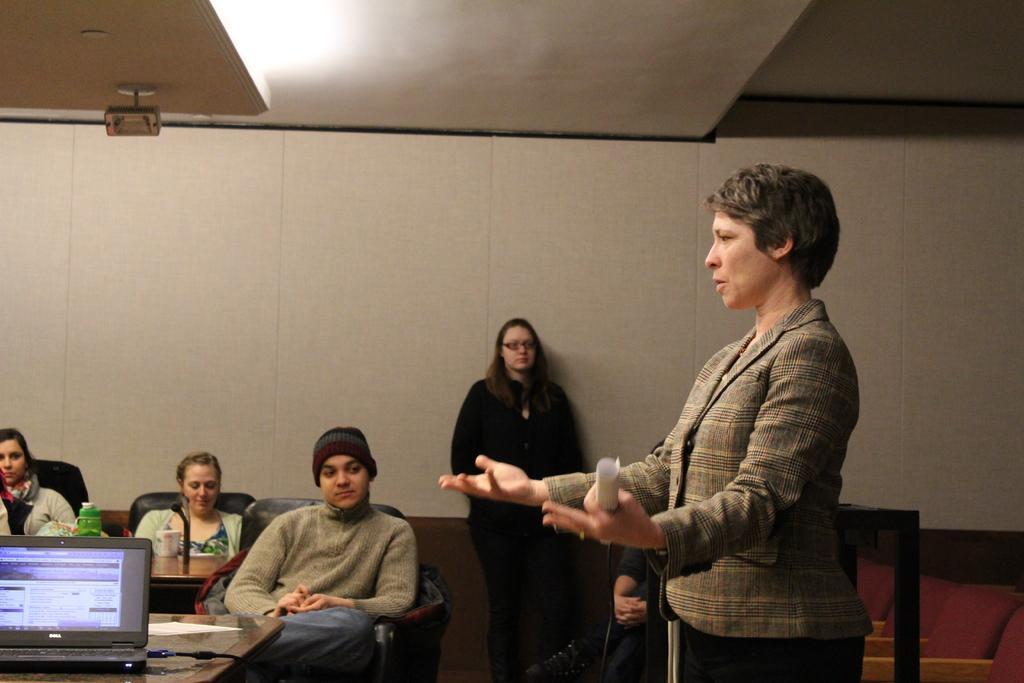Could you give a brief overview of what you see in this image? Here in this picture we can see a woman standing and we can see a paper in her hand and she is trying to explain something to the people who are sitting in front of her on the chairs over there and we can see a table in front of them and on that table we can see a laptop present and beside her we can see another woman standing over the wall and at the top we can see a projector and a light present over there. 